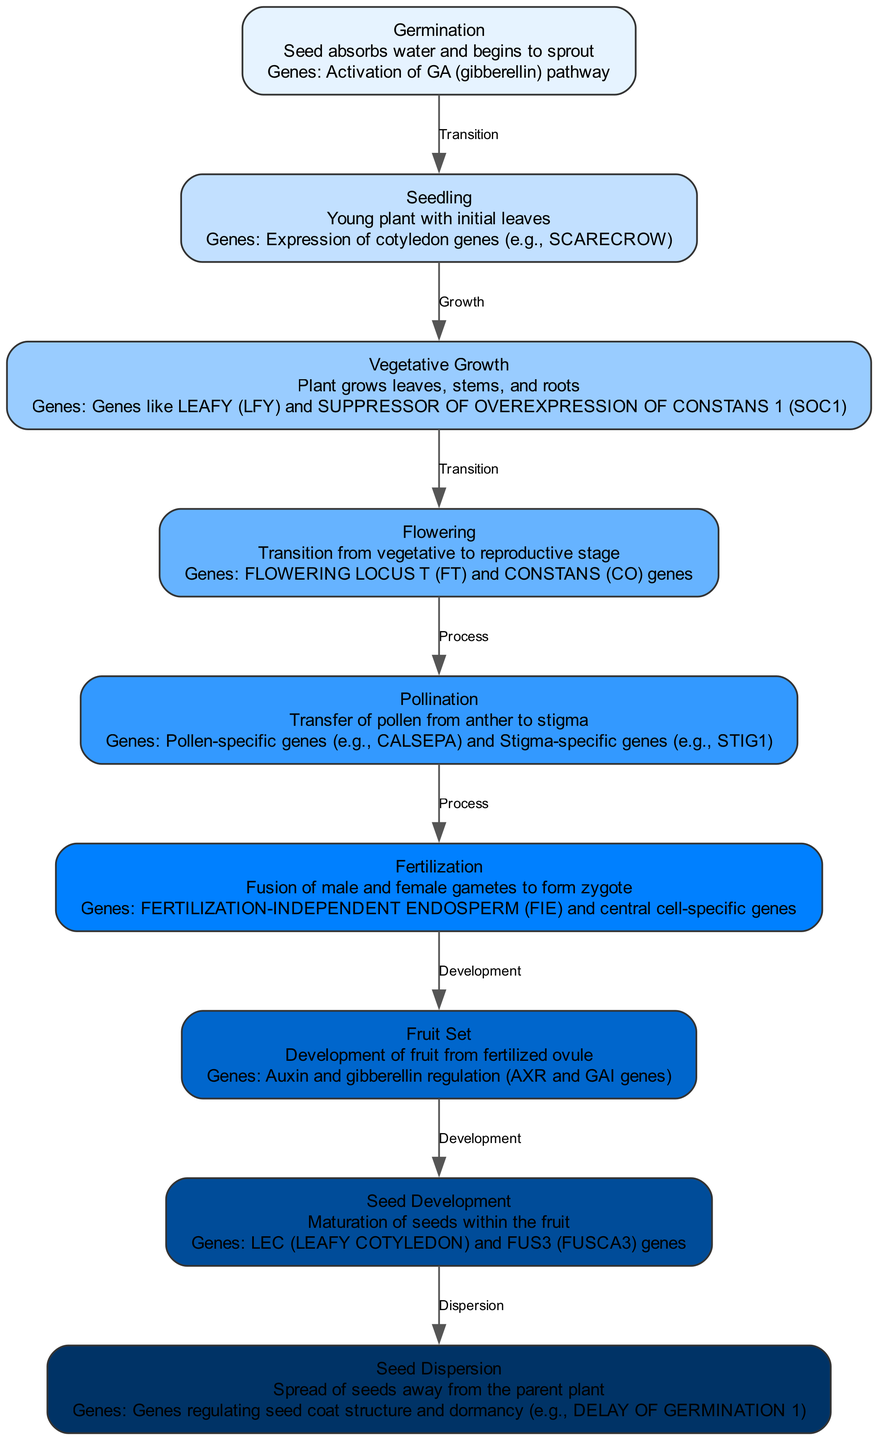What is the first stage in the plant lifecycle? The first stage listed in the diagram is "Germination," where the seed absorbs water and begins to sprout.
Answer: Germination How many stages are there in total in the plant lifecycle? The diagram outlines eight stages, from germination to seed dispersion.
Answer: Eight What genetic expression is activated during flowering? "FLOWERING LOCUS T (FT) and CONSTANS (CO) genes" is the genetic expression activated during the flowering stage.
Answer: FLOWERING LOCUS T (FT) and CONSTANS (CO) genes Which stage comes directly after fertilization? According to the diagram, the stage that follows fertilization is "Fruit Set."
Answer: Fruit Set What is the relationship between seedling and vegetative growth? The relationship shown in the diagram indicates a "Growth" transition from Seedling to Vegetative Growth.
Answer: Growth Which stage involves the development of fruit? The stage where fruit is developed from the fertilized ovule is "Fruit Set," as indicated in the diagram.
Answer: Fruit Set What is the last stage in the lifecycle that involves genetic regulation for seed dormancy? The last stage in the lifecycle represented in the diagram, which includes genetic regulation for seed dormancy, is "Seed Dispersion."
Answer: Seed Dispersion Which genetic expression is associated with the seed development stage? "LEC (LEAFY COTYLEDON) and FUS3 (FUSCA3) genes" are linked to the seed development stage as per the diagram.
Answer: LEC (LEAFY COTYLEDON) and FUS3 (FUSCA3) genes How does pollination relate to fertilization? The diagram shows that pollination is a "Process" that leads to fertilization, indicating a sequential relationship.
Answer: Process 